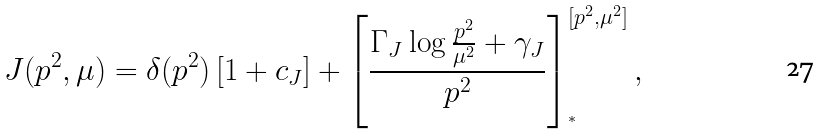Convert formula to latex. <formula><loc_0><loc_0><loc_500><loc_500>J ( p ^ { 2 } , \mu ) = \delta ( p ^ { 2 } ) \left [ 1 + c _ { J } \right ] + \left [ \frac { \Gamma _ { J } \log \frac { p ^ { 2 } } { \mu ^ { 2 } } + \gamma _ { J } } { p ^ { 2 } } \right ] ^ { [ p ^ { 2 } , \mu ^ { 2 } ] } _ { ^ { * } } ,</formula> 